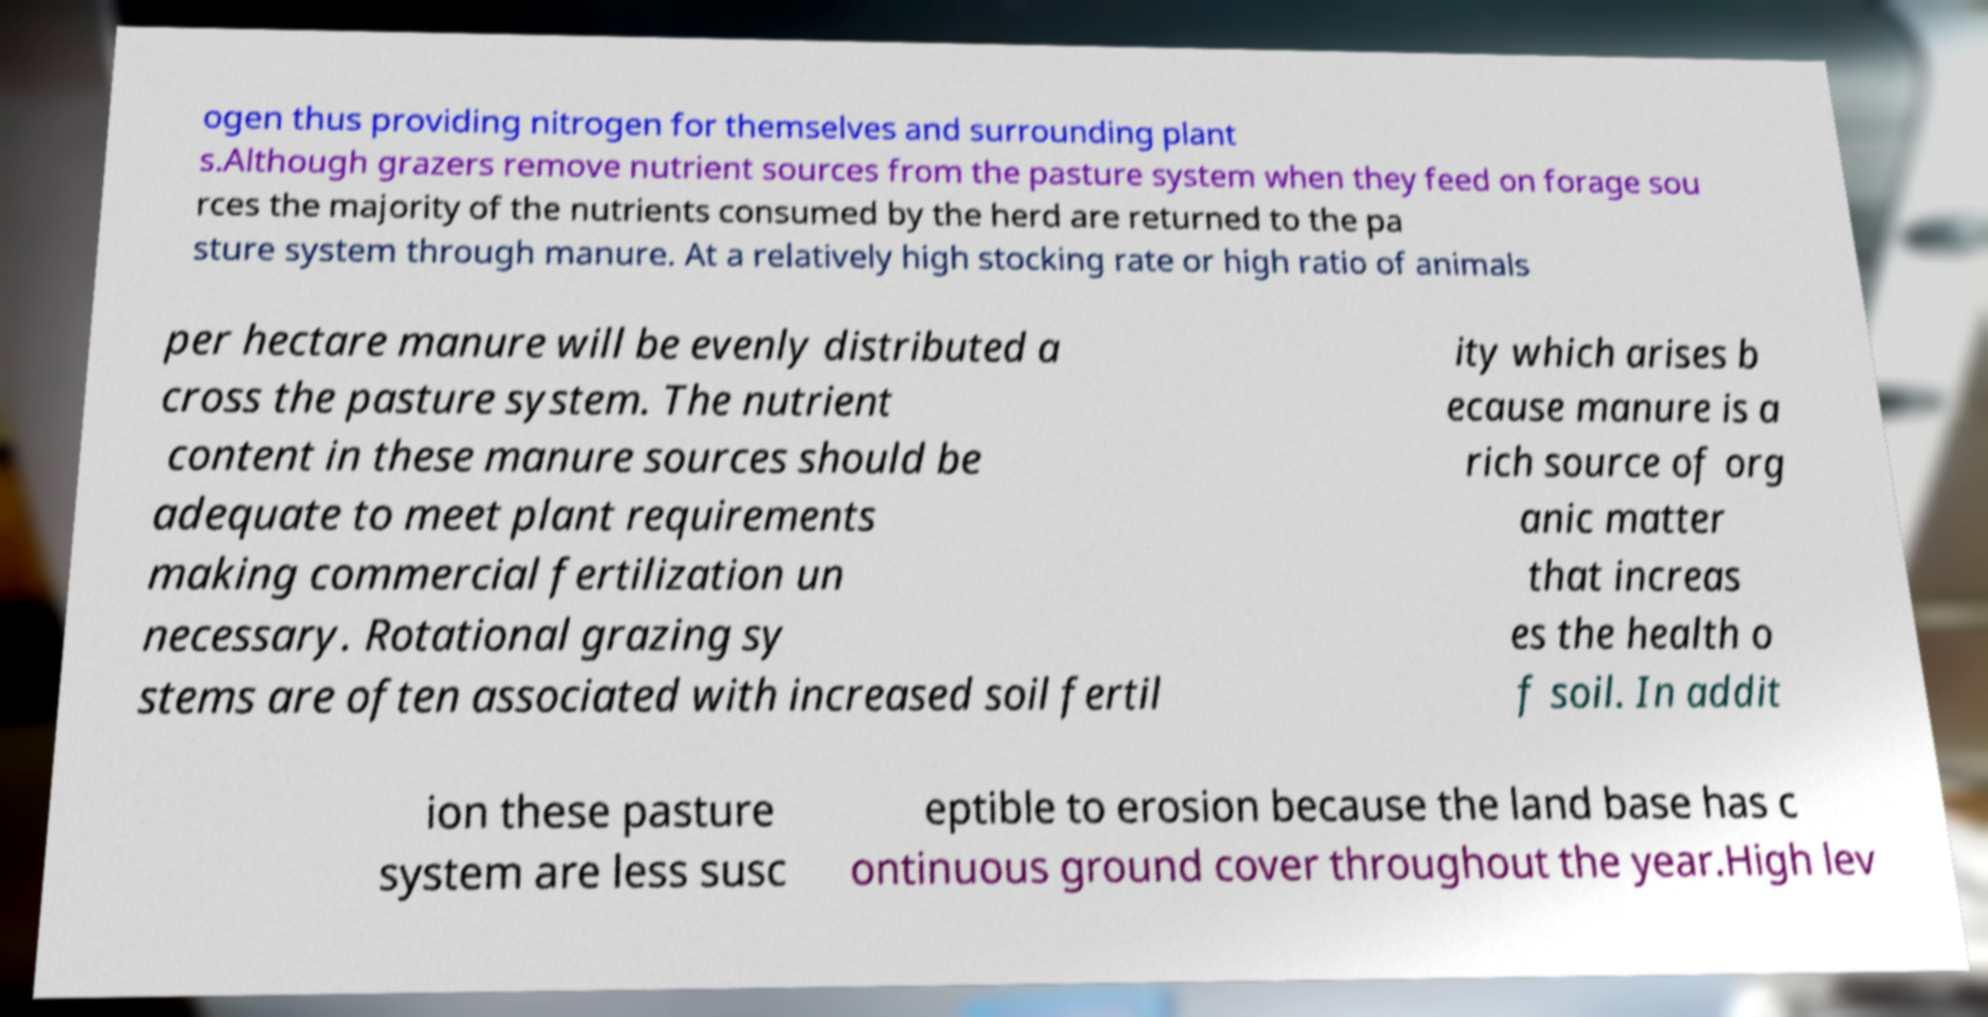Can you read and provide the text displayed in the image?This photo seems to have some interesting text. Can you extract and type it out for me? ogen thus providing nitrogen for themselves and surrounding plant s.Although grazers remove nutrient sources from the pasture system when they feed on forage sou rces the majority of the nutrients consumed by the herd are returned to the pa sture system through manure. At a relatively high stocking rate or high ratio of animals per hectare manure will be evenly distributed a cross the pasture system. The nutrient content in these manure sources should be adequate to meet plant requirements making commercial fertilization un necessary. Rotational grazing sy stems are often associated with increased soil fertil ity which arises b ecause manure is a rich source of org anic matter that increas es the health o f soil. In addit ion these pasture system are less susc eptible to erosion because the land base has c ontinuous ground cover throughout the year.High lev 